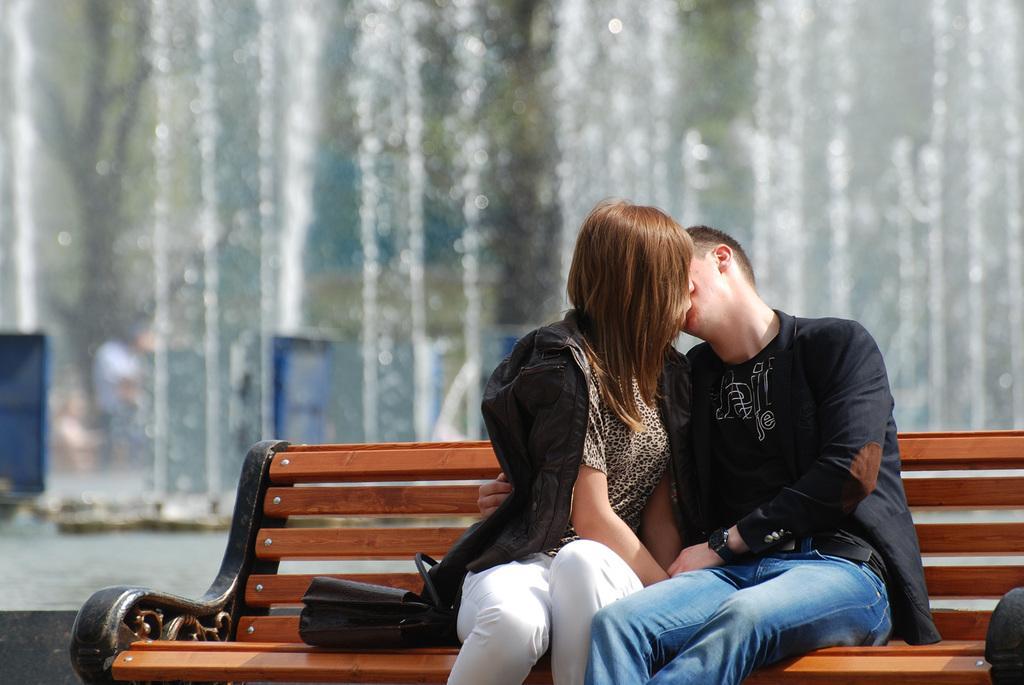Please provide a concise description of this image. In this image, I can see a bag and two persons sitting on a wooden bench. Behind the two persons, I can see a fountain. There is a blurred background. 